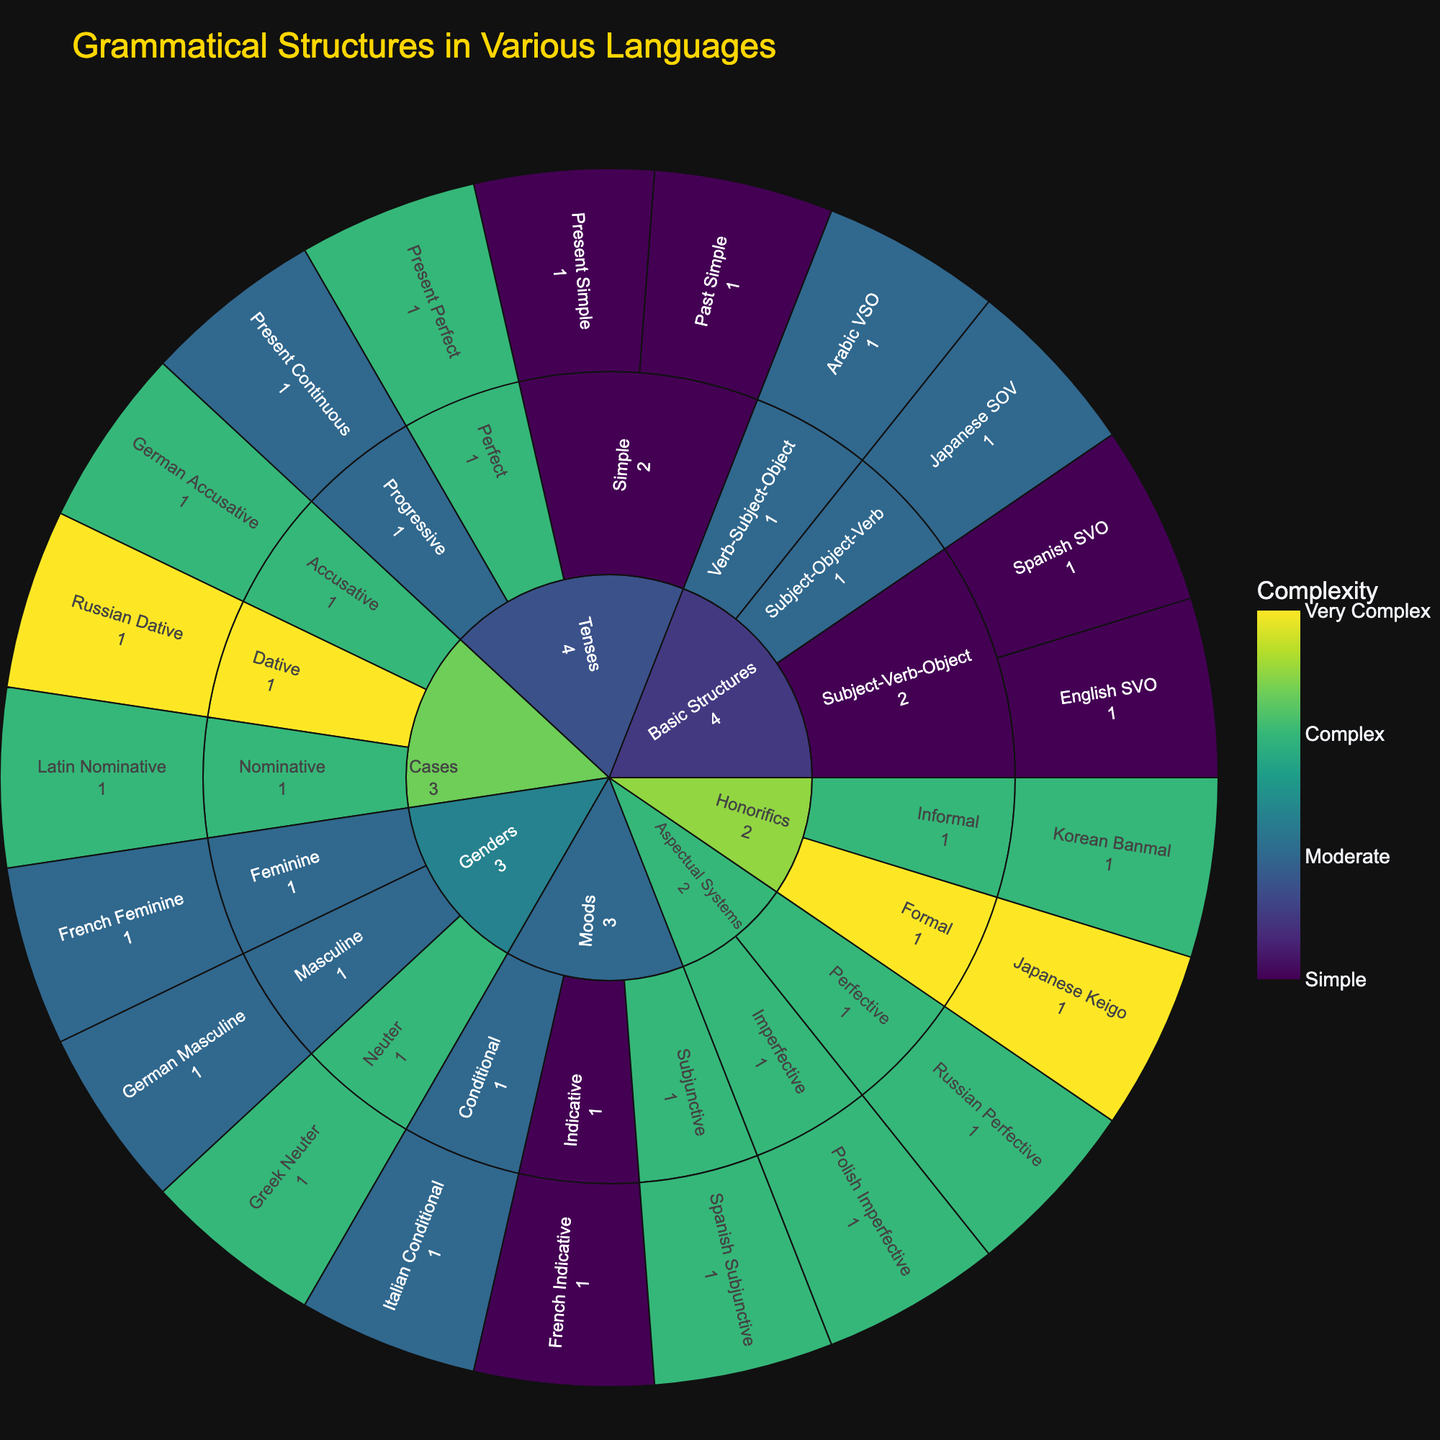What is the title of the Sunburst Plot? The title is displayed at the top of the figure. By just reading this area, one can identify the title.
Answer: Grammatical Structures in Various Languages How many subcategories are there under 'Basic Structures'? Identify the segment labeled 'Basic Structures' and count the distinct sections directly under it, which represent the subcategories.
Answer: 3 Which grammatical structure has the highest complexity in the ‘Honorifics’ category? Look for the segment labeled ‘Honorifics,’ then identify the structure that has the highest value labeled for complexity within this segment.
Answer: Japanese Keigo How many structures have a complexity level of 3? Scan the figure for all sections where the complexity color bar indicates a complexity of 3, then count each occurrence.
Answer: 6 What is the complexity level of ‘Italian Conditional’? Locate the segment labeled ‘Moods,’ then identify the subcategory ‘Conditional’ and find ‘Italian Conditional’ to check its complexity level.
Answer: 2 Compare the complexity between ‘Japanese SOV’ and ‘Arabic VSO’ structures. Which one is more complex? Identify both structures under ‘Basic Structures’ and compare their respective complexity levels.
Answer: They have the same complexity How does the complexity of ‘German Accusative’ compare to ‘French Indicative’? Find both structures under their respective categories and subcategories, compare their complexity levels.
Answer: German Accusative is more complex Which category has the most complex grammatical structure and what is that structure? Identify the structure with the highest complexity by observing the color gradients and labels, then trace back to its parent category.
Answer: Honorifics, Japanese Keigo What is the most complex structure in the ‘Cases’ category? Find the ‘Cases’ category and check the complexity levels of all its structures to identify the highest one.
Answer: Russian Dative How many structures are there under the ‘Tenses’ category? Identify the segment labeled ‘Tenses,’ then count all individual structures under its subcategories.
Answer: 4 